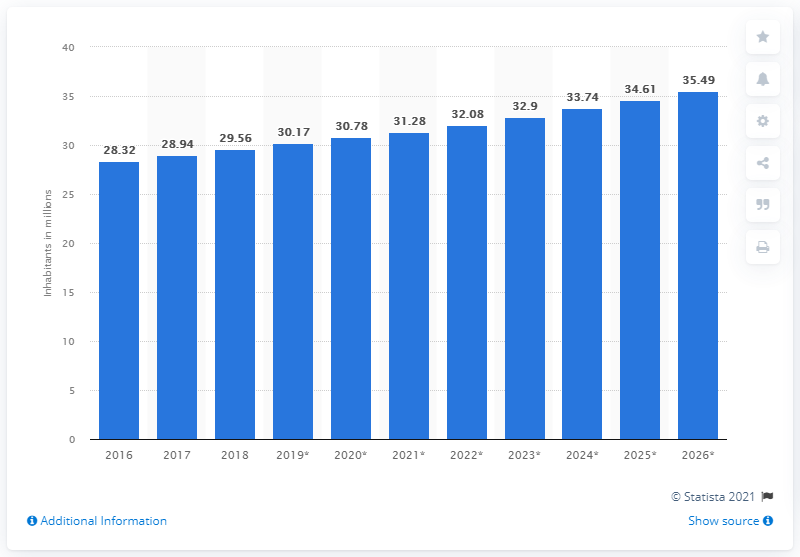Draw attention to some important aspects in this diagram. In 2020, the population of Ghana was approximately 30.78 million. 